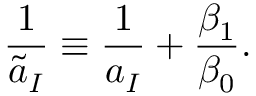<formula> <loc_0><loc_0><loc_500><loc_500>{ \frac { 1 } { \tilde { a } _ { I } } } \equiv \frac { 1 } { a _ { I } } + { \frac { \beta _ { 1 } } { \beta _ { 0 } } } .</formula> 